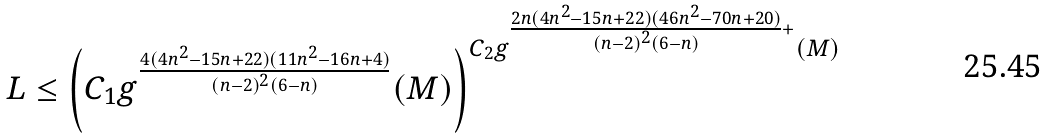Convert formula to latex. <formula><loc_0><loc_0><loc_500><loc_500>\begin{array} { l } L \leq \left ( C _ { 1 } g ^ { \frac { 4 ( 4 n ^ { 2 } - 1 5 n + 2 2 ) ( 1 1 n ^ { 2 } - 1 6 n + 4 ) } { ( n - 2 ) ^ { 2 } ( 6 - n ) } } ( M ) \right ) ^ { C _ { 2 } g ^ { \frac { 2 n ( 4 n ^ { 2 } - 1 5 n + 2 2 ) ( 4 6 n ^ { 2 } - 7 0 n + 2 0 ) } { ( n - 2 ) ^ { 2 } ( 6 - n ) } + } ( M ) } \end{array}</formula> 